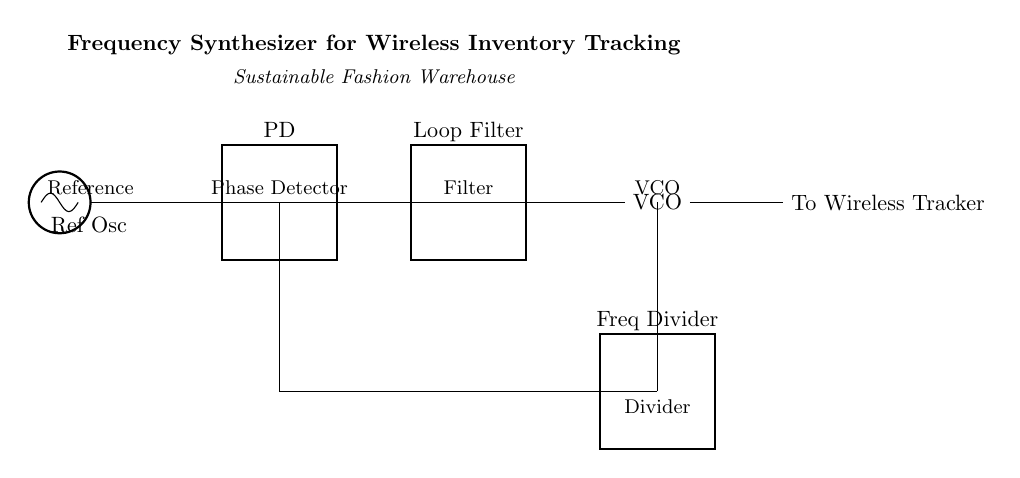What component is used as the reference for the oscillator? The circuit includes a reference oscillator labeled 'Ref Osc' which provides a stable frequency reference necessary for the phase detection process.
Answer: Ref Osc What is the role of the phase detector in this circuit? The phase detector, labeled 'PD', compares the input frequency from the reference oscillator with the frequency from the VCO to ensure synchronization and generates an error signal based on the phase difference.
Answer: Synchronization What type of component is the VCO in this circuit? The VCO (Voltage-Controlled Oscillator) is a critical component that generates an output frequency that can be controlled by the voltage from the loop filter, allowing for frequency modulation.
Answer: Oscillator How does the frequency divider function in the context of this circuit? The frequency divider reduces the output frequency of the VCO to match the reference frequency from the reference oscillator, ensuring that the output remains in sync with the input.
Answer: Reduce frequency How many main components are there in this frequency synthesizer circuit? The components listed in the circuit include four main parts: reference oscillator, phase detector, loop filter, and VCO, along with a frequency divider, totaling five main components.
Answer: Five What is the primary output of the VCO in this circuit? The primary output of the VCO is the frequency signal that is sent to the wireless tracker, which is used for tracking inventory wirelessly in the sustainable fashion warehouse context.
Answer: To Wireless Tracker 